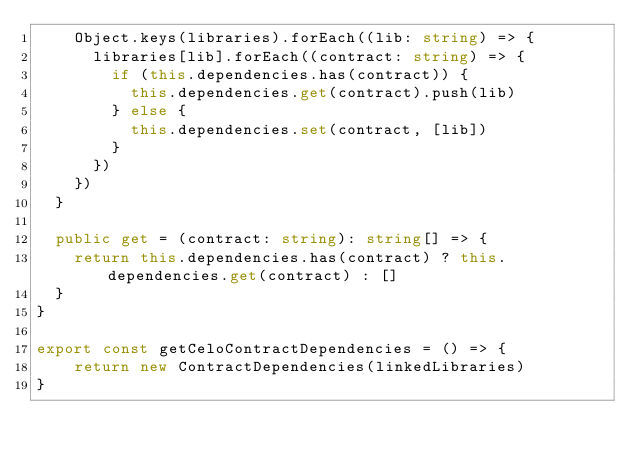Convert code to text. <code><loc_0><loc_0><loc_500><loc_500><_TypeScript_>    Object.keys(libraries).forEach((lib: string) => {
      libraries[lib].forEach((contract: string) => {
        if (this.dependencies.has(contract)) {
          this.dependencies.get(contract).push(lib)
        } else {
          this.dependencies.set(contract, [lib])
        }
      })
    })
  }

  public get = (contract: string): string[] => {
    return this.dependencies.has(contract) ? this.dependencies.get(contract) : []
  }
}

export const getCeloContractDependencies = () => {
    return new ContractDependencies(linkedLibraries)
}
</code> 